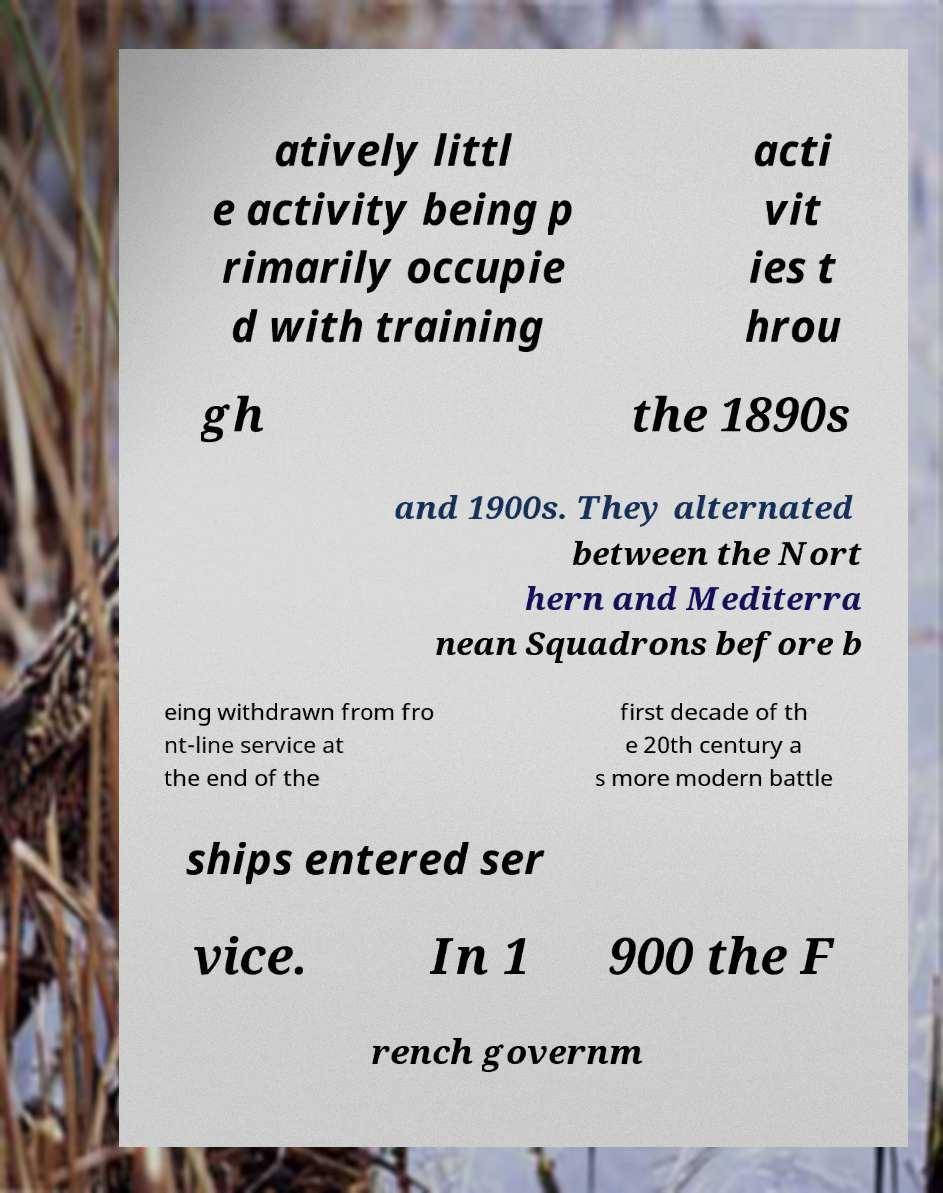Please identify and transcribe the text found in this image. atively littl e activity being p rimarily occupie d with training acti vit ies t hrou gh the 1890s and 1900s. They alternated between the Nort hern and Mediterra nean Squadrons before b eing withdrawn from fro nt-line service at the end of the first decade of th e 20th century a s more modern battle ships entered ser vice. In 1 900 the F rench governm 